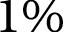Convert formula to latex. <formula><loc_0><loc_0><loc_500><loc_500>1 \%</formula> 